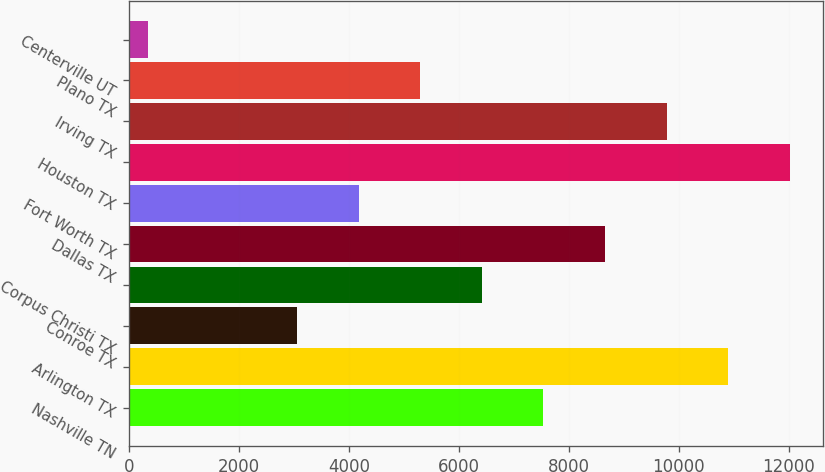Convert chart to OTSL. <chart><loc_0><loc_0><loc_500><loc_500><bar_chart><fcel>Nashville TN<fcel>Arlington TX<fcel>Conroe TX<fcel>Corpus Christi TX<fcel>Dallas TX<fcel>Fort Worth TX<fcel>Houston TX<fcel>Irving TX<fcel>Plano TX<fcel>Centerville UT<nl><fcel>7539.8<fcel>10900.4<fcel>3059<fcel>6419.6<fcel>8660<fcel>4179.2<fcel>12020.6<fcel>9780.2<fcel>5299.4<fcel>348<nl></chart> 